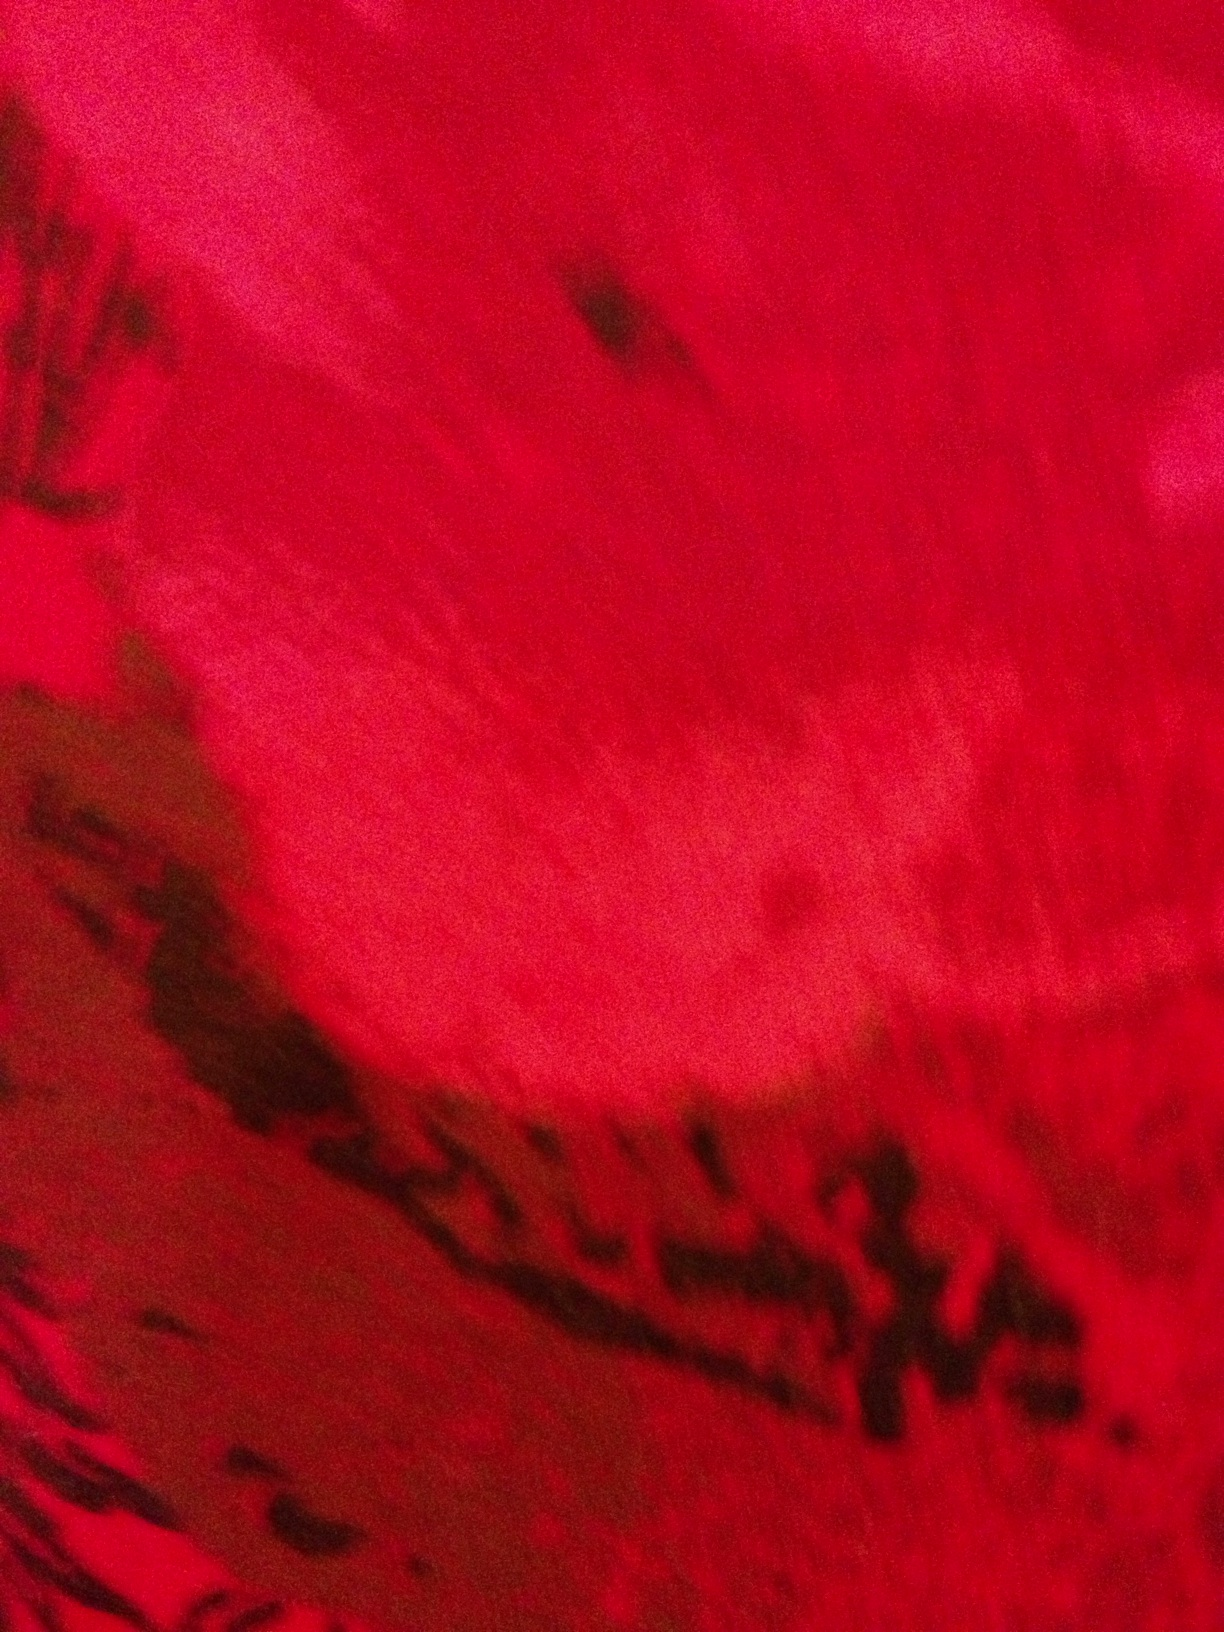Can you make a creative interpretation of this image in a fantasy setting? In a fantasy world, this image might depict the surface of a rare, magical stone known as the Crimson Heart. Legends say that anyone who possesses the Crimson Heart gains untold power, but only those with a pure heart can wield its true potential. The swirling patterns and deep red hues are said to be the steady beat of the stone's own life force, pulsing with energy. Describe an adventure involving the Crimson Heart. A brave knight named Seraphina sets out on a perilous journey to retrieve the Crimson Heart from the clutches of the dragon, Azarath, who has kept it hidden deep within the heart of an active volcano. Along her journey, Seraphina encounters treacherous landscapes, from dense enchanted forests to icy mountain peaks, each harboring their own trials. With her loyal companion, a talking eagle named Elion, she faces numerous challenges, including deceitful goblins and ancient curses. Upon reaching the volcano, Seraphina must confront Azarath in an epic battle where wits and bravery are her strongest allies. In the end, her pure intentions and unyielding courage help her succeed, allowing her to harness the Crimson Heart's power to bring peace and prosperity to her homeland. What might be the short description of the Crimson Heart's powers? The Crimson Heart grants its bearer immense strength, the ability to heal wounds, and the power to control natural elements such as fire and earth. However, its true potential reveals itself only to those with pure intentions and a noble spirit. 